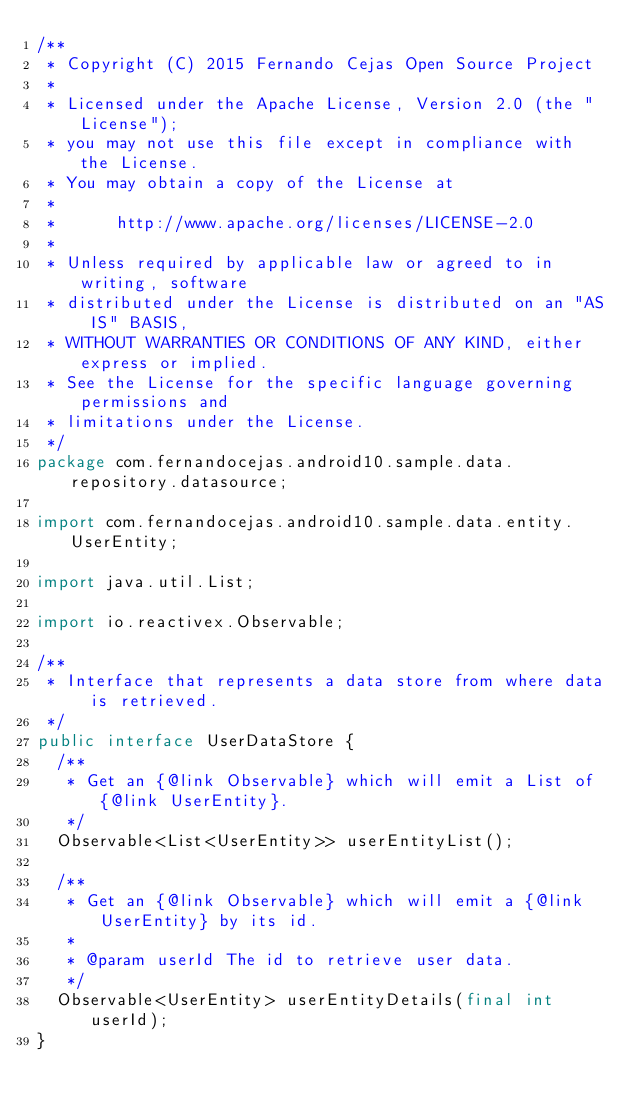Convert code to text. <code><loc_0><loc_0><loc_500><loc_500><_Java_>/**
 * Copyright (C) 2015 Fernando Cejas Open Source Project
 *
 * Licensed under the Apache License, Version 2.0 (the "License");
 * you may not use this file except in compliance with the License.
 * You may obtain a copy of the License at
 *
 *      http://www.apache.org/licenses/LICENSE-2.0
 *
 * Unless required by applicable law or agreed to in writing, software
 * distributed under the License is distributed on an "AS IS" BASIS,
 * WITHOUT WARRANTIES OR CONDITIONS OF ANY KIND, either express or implied.
 * See the License for the specific language governing permissions and
 * limitations under the License.
 */
package com.fernandocejas.android10.sample.data.repository.datasource;

import com.fernandocejas.android10.sample.data.entity.UserEntity;

import java.util.List;

import io.reactivex.Observable;

/**
 * Interface that represents a data store from where data is retrieved.
 */
public interface UserDataStore {
  /**
   * Get an {@link Observable} which will emit a List of {@link UserEntity}.
   */
  Observable<List<UserEntity>> userEntityList();

  /**
   * Get an {@link Observable} which will emit a {@link UserEntity} by its id.
   *
   * @param userId The id to retrieve user data.
   */
  Observable<UserEntity> userEntityDetails(final int userId);
}
</code> 